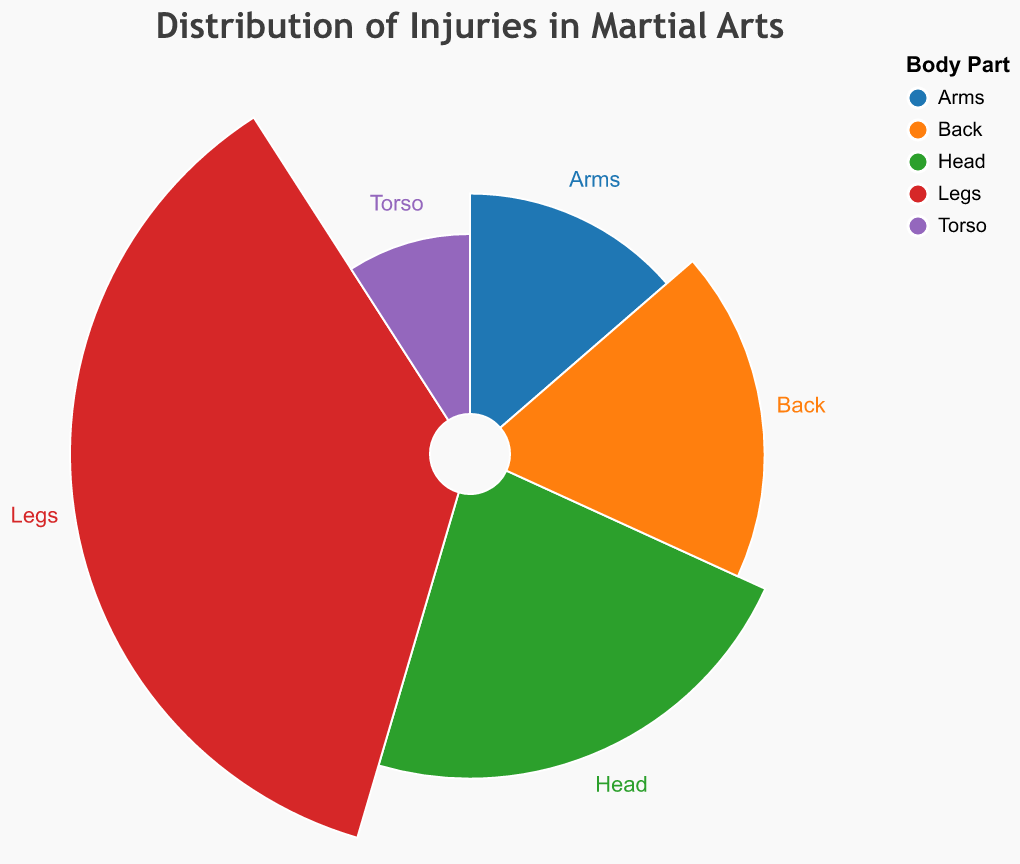What is the title of the chart? The title of the chart is prominently displayed at the top and reads "Distribution of Injuries in Martial Arts".
Answer: Distribution of Injuries in Martial Arts Which body part has the highest number of injuries? By observing the chart, the segment for Legs is clearly the largest in size, indicating that it has the most athletes affected.
Answer: Legs How many athletes are affected by injuries in the torso? Looking at the chart, the segment labeled "Torso" shows a total of 10 athletes affected.
Answer: 10 What is the sum of athletes affected by injuries in the head and arms? According to the chart, the head has 25 athletes affected and the arms have 15. Summing these up: 25 + 15 = 40.
Answer: 40 Which body part has fewer injuries: back or torso? Comparing the sizes of the segments, the torso has 10 athletes affected while the back has 20, which means the torso has fewer injuries.
Answer: Torso Which two body parts together account for the same number of injuries as the legs? The legs have 40 athletes affected. The back (20) and head (25) combined sum to 45, which does not match. However, adding arms (15) and head (25) sums to 40.
Answer: Arms and Head What is the difference in the number of athletes affected between the back and the head? The back has 20 athletes affected, and the head has 25 athletes affected. The difference is 25 - 20 = 5.
Answer: 5 Is the radius of segments proportional to the number of athletes affected? By comparing all the segments, we notice the radius varies according to the number of athletes affected, suggesting a proportional relationship.
Answer: Yes What proportion of total injuries does the torso segment represent? First calculate the total number of athletes affected: 25 (Head) + 15 (Arms) + 40 (Legs) + 10 (Torso) + 20 (Back) = 110. The torso segment represents 10 out of 110, so 10/110 = 1/11 ≈ 9.09%.
Answer: 9.09% Which body part's segment is approximately twice the size of another, in terms of athletes affected? Observing the chart, the back (20 athletes) has a segment about twice the size of the torso (10 athletes).
Answer: Back and Torso 